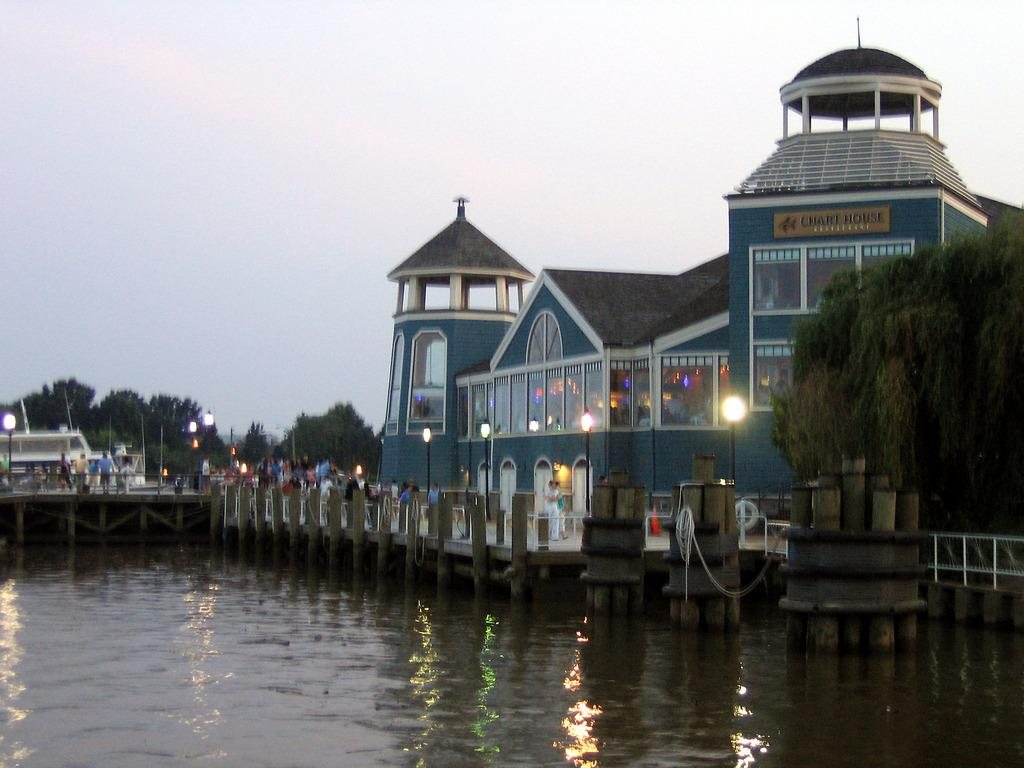<image>
Write a terse but informative summary of the picture. The Chart House Restaurant overlooks a shimmering lake. 